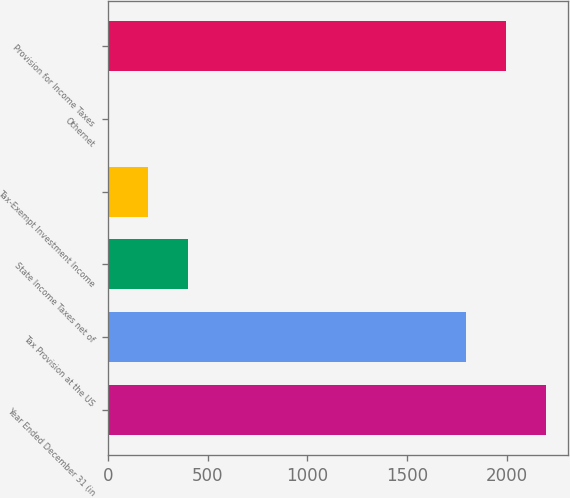Convert chart to OTSL. <chart><loc_0><loc_0><loc_500><loc_500><bar_chart><fcel>Year Ended December 31 (in<fcel>Tax Provision at the US<fcel>State Income Taxes net of<fcel>Tax-Exempt Investment Income<fcel>Othernet<fcel>Provision for Income Taxes<nl><fcel>2196.8<fcel>1796<fcel>401.8<fcel>201.4<fcel>1<fcel>1996.4<nl></chart> 